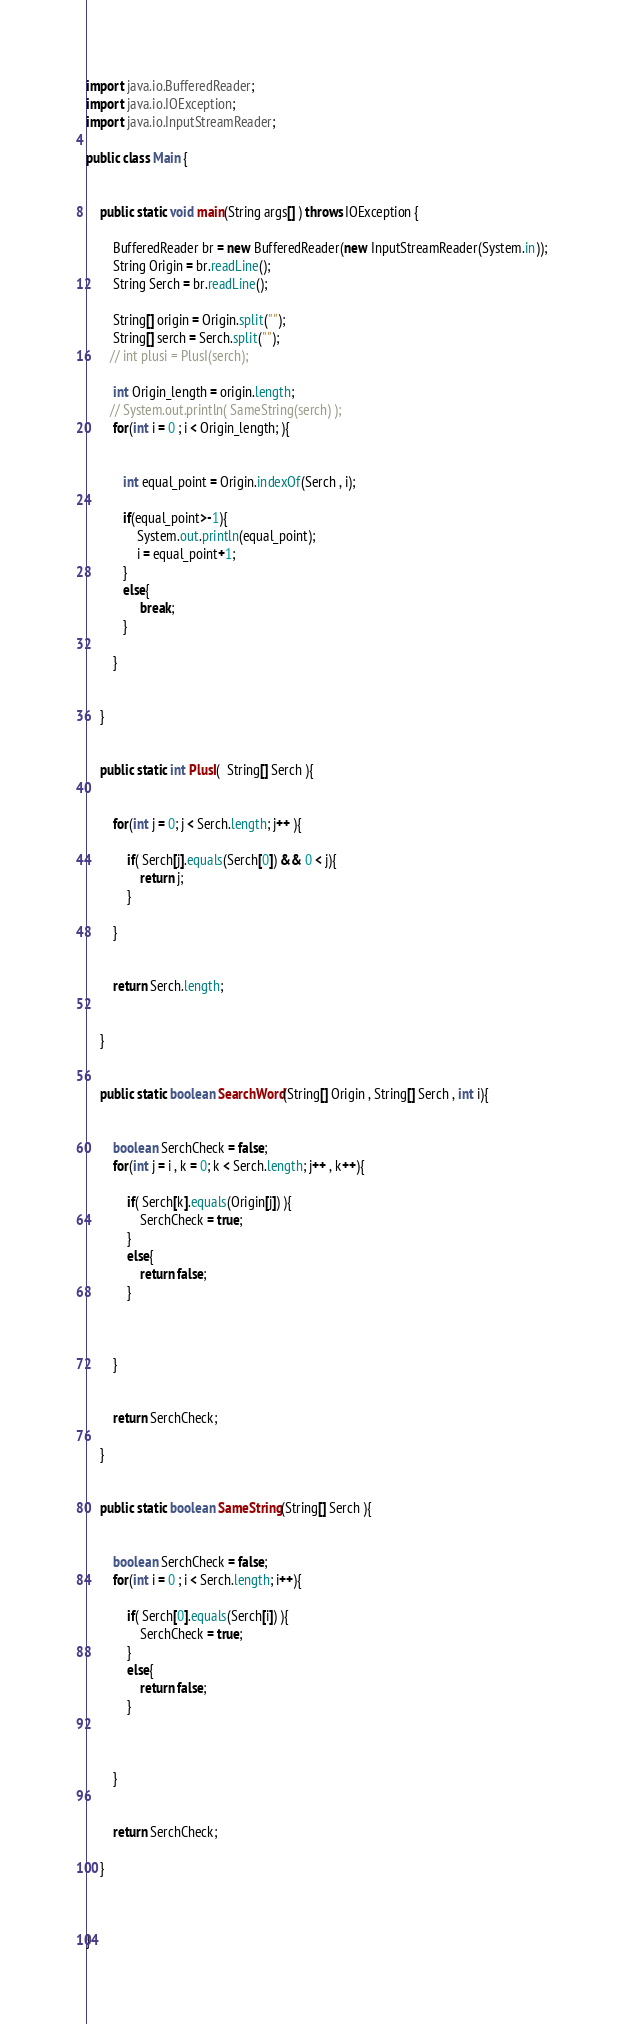Convert code to text. <code><loc_0><loc_0><loc_500><loc_500><_Java_>import java.io.BufferedReader;
import java.io.IOException;
import java.io.InputStreamReader;

public class Main {


    public static void main(String args[] ) throws IOException {

        BufferedReader br = new BufferedReader(new InputStreamReader(System.in));
        String Origin = br.readLine();
        String Serch = br.readLine();

        String[] origin = Origin.split("");
        String[] serch = Serch.split("");
       // int plusi = PlusI(serch);

        int Origin_length = origin.length;
       // System.out.println( SameString(serch) );
        for(int i = 0 ; i < Origin_length; ){


           int equal_point = Origin.indexOf(Serch , i);

           if(equal_point>-1){
        	   System.out.println(equal_point);
        	   i = equal_point+1;
           }
           else{
        	    break;
           }

        }


    }


    public static int PlusI(  String[] Serch ){


    	for(int j = 0; j < Serch.length; j++ ){

    	    if( Serch[j].equals(Serch[0]) && 0 < j){
    	    	return j;
    	    }

    	}


        return Serch.length;


    }


    public static boolean SearchWord(String[] Origin , String[] Serch , int i){


    	boolean SerchCheck = false;
    	for(int j = i , k = 0; k < Serch.length; j++ , k++){

    	    if( Serch[k].equals(Origin[j]) ){
    	    	SerchCheck = true;
    	    }
    	    else{
    	    	return false;
    	    }



    	}


    	return SerchCheck;

    }


    public static boolean SameString(String[] Serch ){


    	boolean SerchCheck = false;
    	for(int i = 0 ; i < Serch.length; i++){

    	    if( Serch[0].equals(Serch[i]) ){
    	    	SerchCheck = true;
    	    }
    	    else{
    	    	return false;
    	    }



    	}


    	return SerchCheck;

    }



}</code> 